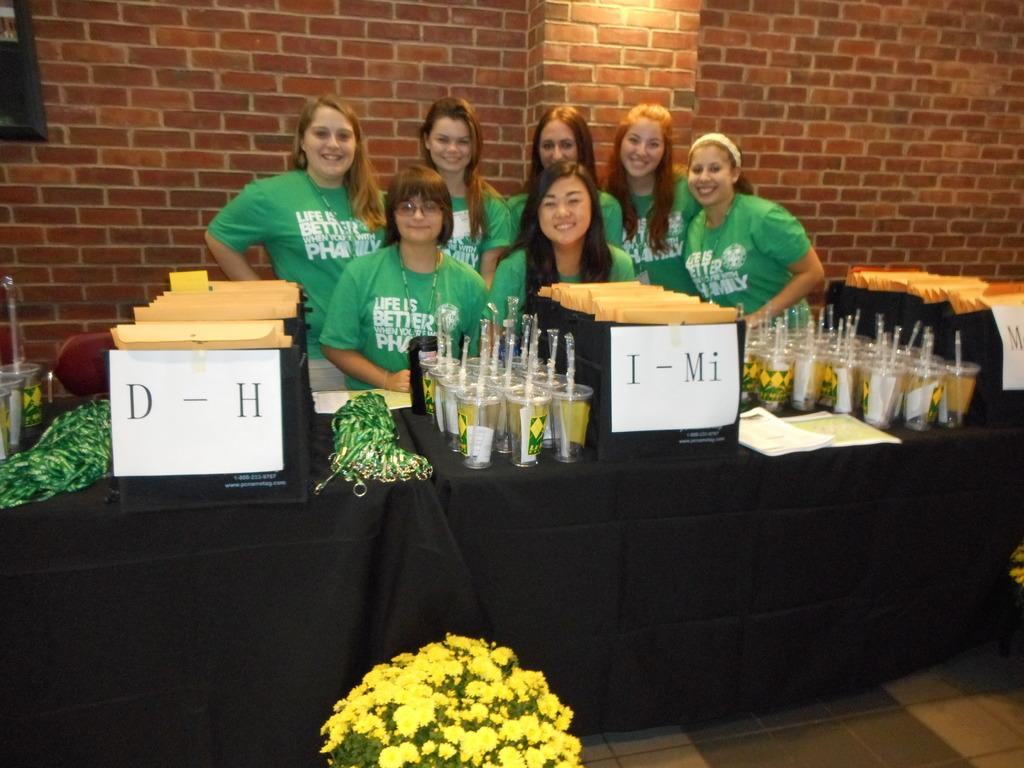What type of plants can be seen in the image? There are flowers in the image. What surface is visible beneath the flowers? There is a floor visible in the image. What is the facial expression of the people in the image? There are people smiling in the image. What are the glasses on the table used for? The glasses with straws in the image are likely used for drinking. What can be found on the table in the image? There are objects on the table in the image. What is present on the wall in the background of the image? There is a frame on the wall in the background of the image. Can you see a twig floating on the lake in the image? There is no lake or twig present in the image. How does the increase in temperature affect the flowers in the image? The image does not provide information about the temperature or any changes in it, so we cannot determine how it affects the flowers. 